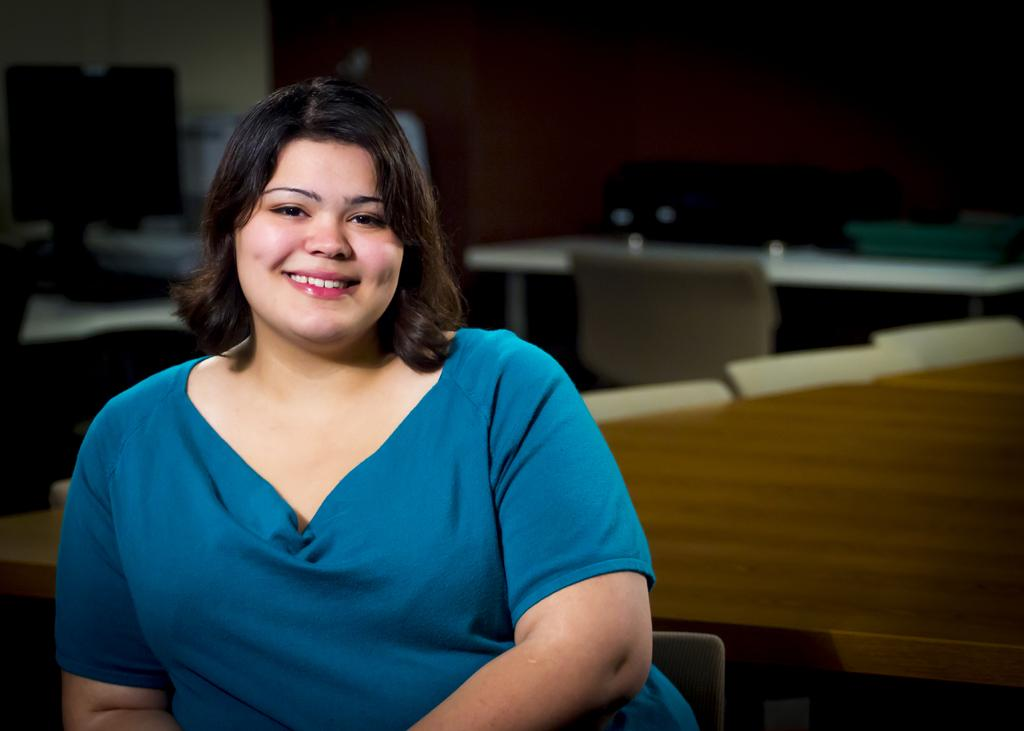Who is the main subject in the image? There is a lady in the image. Can you describe the lady's appearance? The lady has short hair and is wearing a blue color shirt. What can be seen on the desk in the image? There is a system on the desk in the image. What is located on the floor in the image? There is a chair on the floor in the image. Reasoning: Let' Let's think step by step in order to produce the conversation. We start by identifying the main subject in the image, which is the lady. Then, we describe her appearance based on the provided facts. Next, we shift our focus to the objects in the image, such as the desk, system, and chair. Each question is designed to elicit a specific detail about the image that is known from the provided facts. Absurd Question/Answer: In which direction is the lady facing in the image? The provided facts do not mention the direction the lady is facing, so it cannot be determined from the image. What type of pickle is on the desk in the image? There is no pickle present in the image. 